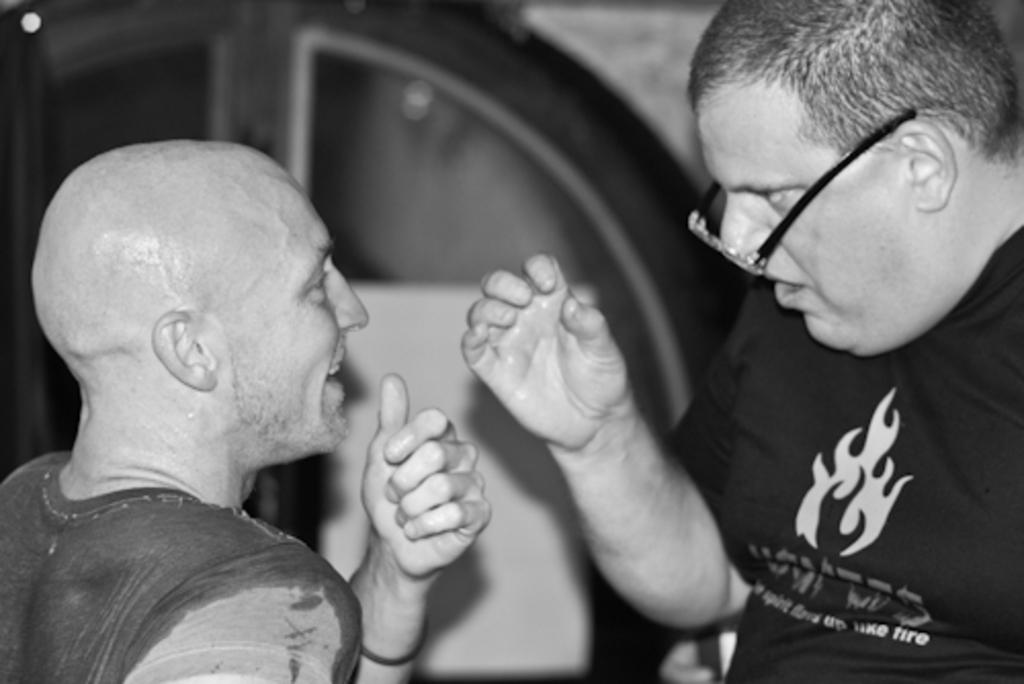What is the appearance of the man in the image? There is a bald man in the image. What is the bald man wearing? The bald man is wearing a t-shirt. Can you describe the man standing in front of the bald man? The man in front is wearing spectacles and a black t-shirt. What can be seen in the background of the image? There is a door visible in the background of the image. What type of yarn is the man in front using to knit in the image? There is no yarn or knitting activity present in the image. How many sticks are visible in the image? There are no sticks visible in the image. 